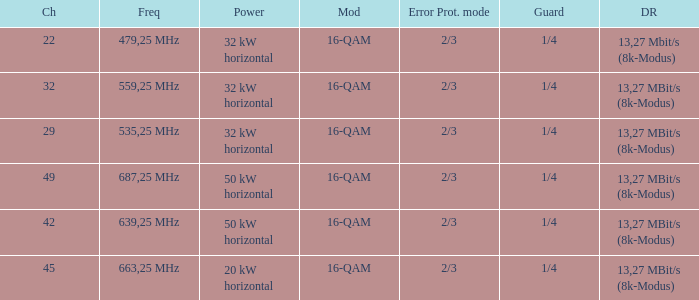Could you parse the entire table? {'header': ['Ch', 'Freq', 'Power', 'Mod', 'Error Prot. mode', 'Guard', 'DR'], 'rows': [['22', '479,25 MHz', '32 kW horizontal', '16-QAM', '2/3', '1/4', '13,27 Mbit/s (8k-Modus)'], ['32', '559,25 MHz', '32 kW horizontal', '16-QAM', '2/3', '1/4', '13,27 MBit/s (8k-Modus)'], ['29', '535,25 MHz', '32 kW horizontal', '16-QAM', '2/3', '1/4', '13,27 MBit/s (8k-Modus)'], ['49', '687,25 MHz', '50 kW horizontal', '16-QAM', '2/3', '1/4', '13,27 MBit/s (8k-Modus)'], ['42', '639,25 MHz', '50 kW horizontal', '16-QAM', '2/3', '1/4', '13,27 MBit/s (8k-Modus)'], ['45', '663,25 MHz', '20 kW horizontal', '16-QAM', '2/3', '1/4', '13,27 MBit/s (8k-Modus)']]} On channel 32, when the power is 32 kW horizontal, what is the modulation? 16-QAM. 